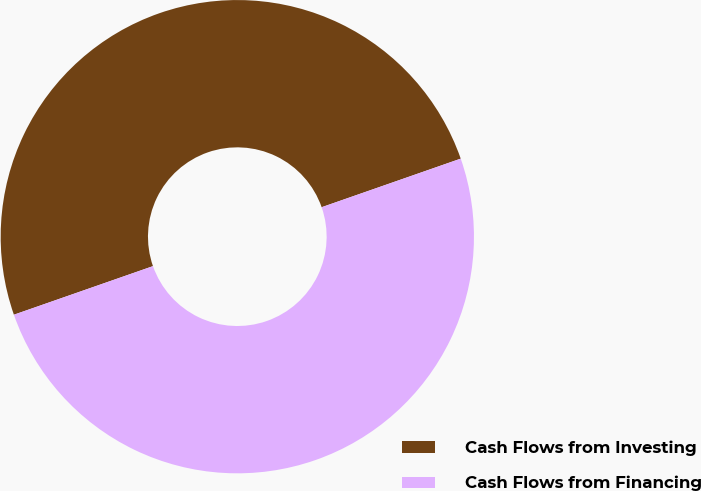Convert chart. <chart><loc_0><loc_0><loc_500><loc_500><pie_chart><fcel>Cash Flows from Investing<fcel>Cash Flows from Financing<nl><fcel>50.0%<fcel>50.0%<nl></chart> 